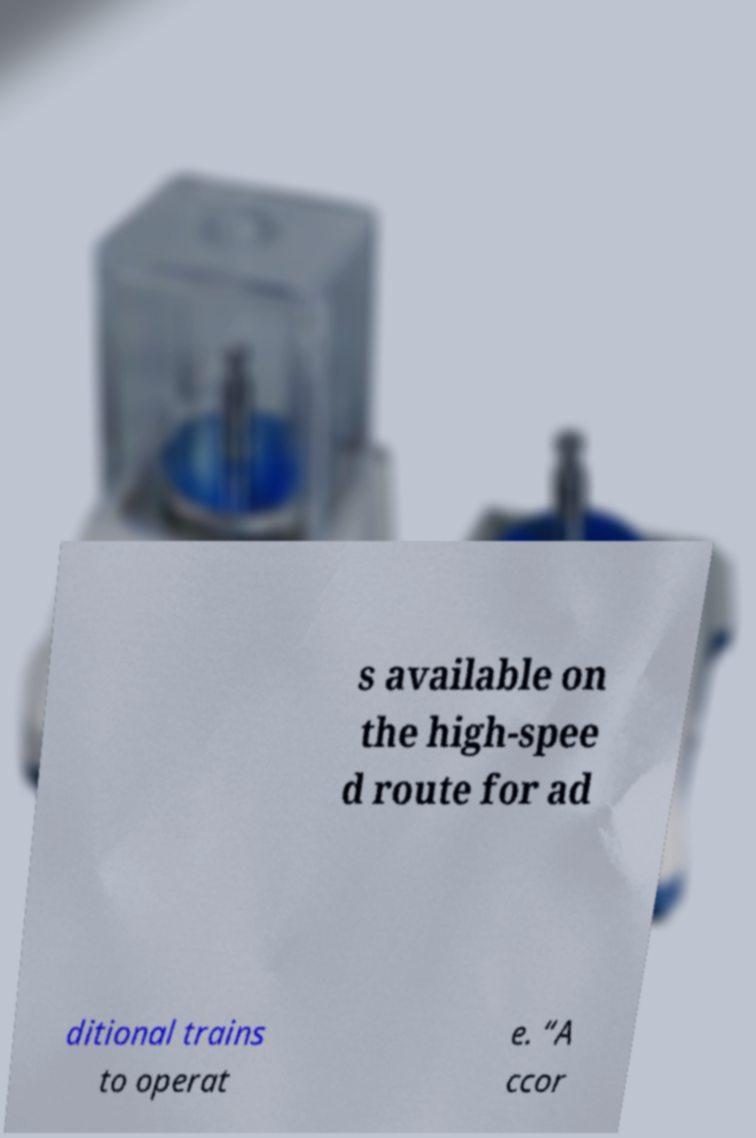What messages or text are displayed in this image? I need them in a readable, typed format. s available on the high-spee d route for ad ditional trains to operat e. “A ccor 